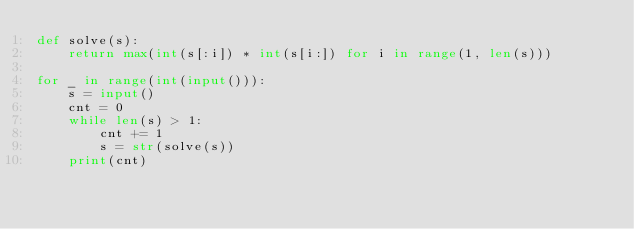<code> <loc_0><loc_0><loc_500><loc_500><_Python_>def solve(s):
    return max(int(s[:i]) * int(s[i:]) for i in range(1, len(s)))

for _ in range(int(input())):
    s = input()
    cnt = 0
    while len(s) > 1:
        cnt += 1
        s = str(solve(s))
    print(cnt)
</code> 